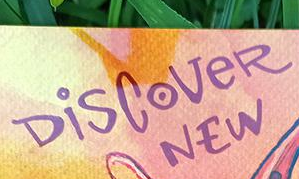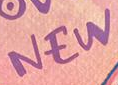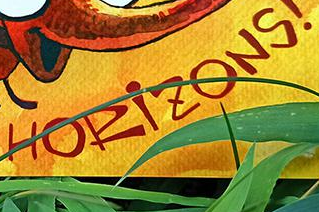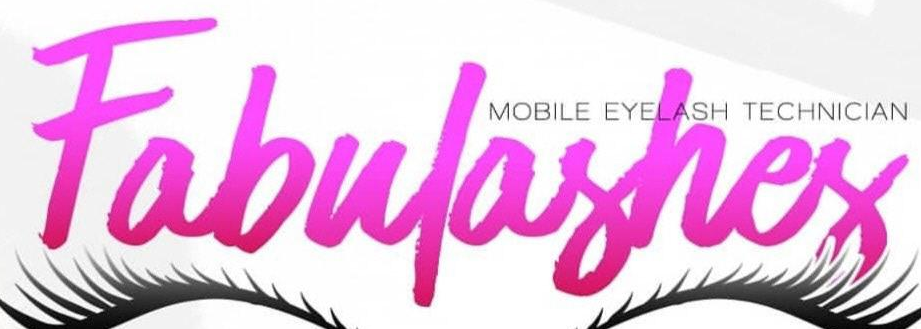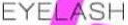What words are shown in these images in order, separated by a semicolon? DiSCoVeR; NEW; HORiZONS; Fabulashes; EYELASH 